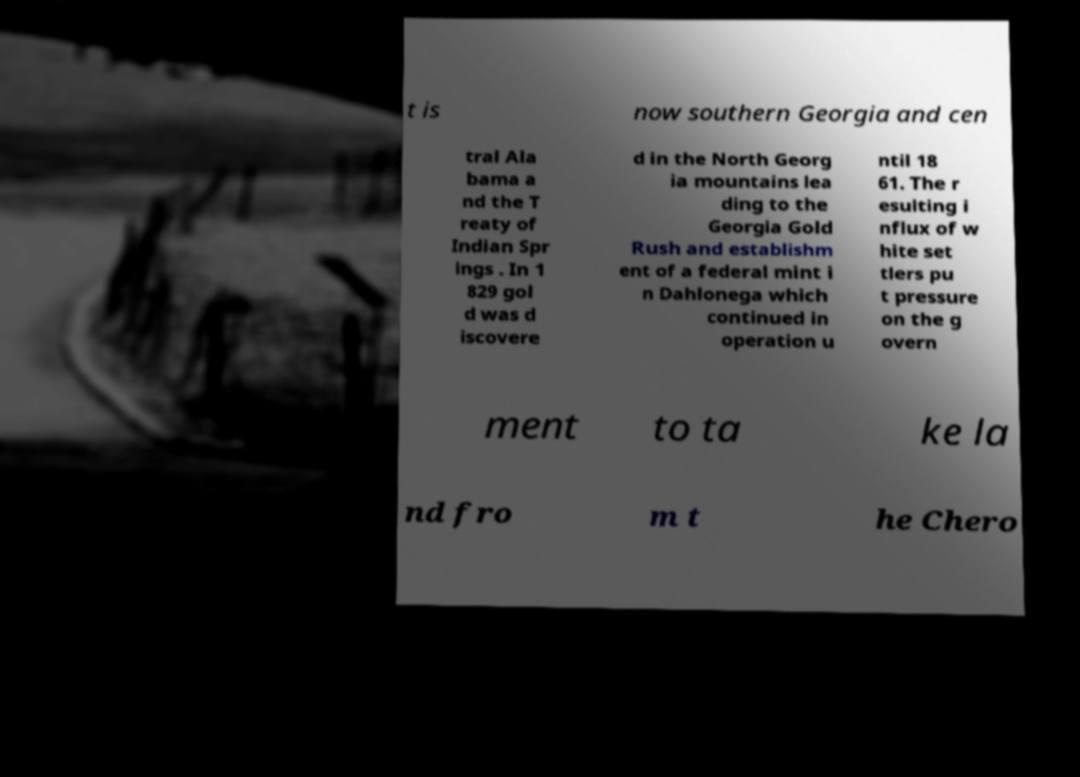For documentation purposes, I need the text within this image transcribed. Could you provide that? t is now southern Georgia and cen tral Ala bama a nd the T reaty of Indian Spr ings . In 1 829 gol d was d iscovere d in the North Georg ia mountains lea ding to the Georgia Gold Rush and establishm ent of a federal mint i n Dahlonega which continued in operation u ntil 18 61. The r esulting i nflux of w hite set tlers pu t pressure on the g overn ment to ta ke la nd fro m t he Chero 